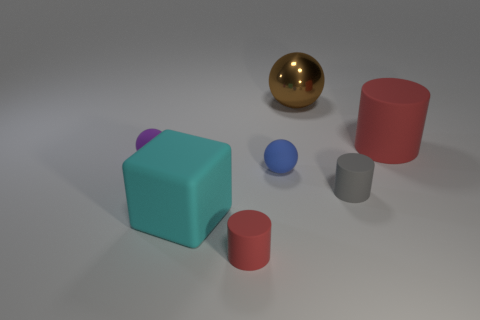Is the red thing left of the large red cylinder made of the same material as the gray thing?
Offer a very short reply. Yes. How many other things are there of the same material as the large cyan object?
Make the answer very short. 5. What material is the tiny red cylinder?
Keep it short and to the point. Rubber. What size is the rubber cylinder that is in front of the tiny gray matte thing?
Make the answer very short. Small. There is a red cylinder behind the blue matte sphere; what number of tiny blue rubber objects are behind it?
Make the answer very short. 0. There is a big thing left of the brown object; is its shape the same as the small object that is right of the small blue rubber sphere?
Make the answer very short. No. How many red rubber things are to the right of the big brown shiny thing and in front of the blue matte thing?
Your response must be concise. 0. Are there any small things of the same color as the big cylinder?
Ensure brevity in your answer.  Yes. What shape is the blue rubber thing that is the same size as the purple matte thing?
Give a very brief answer. Sphere. Are there any big things behind the small blue matte object?
Offer a terse response. Yes. 